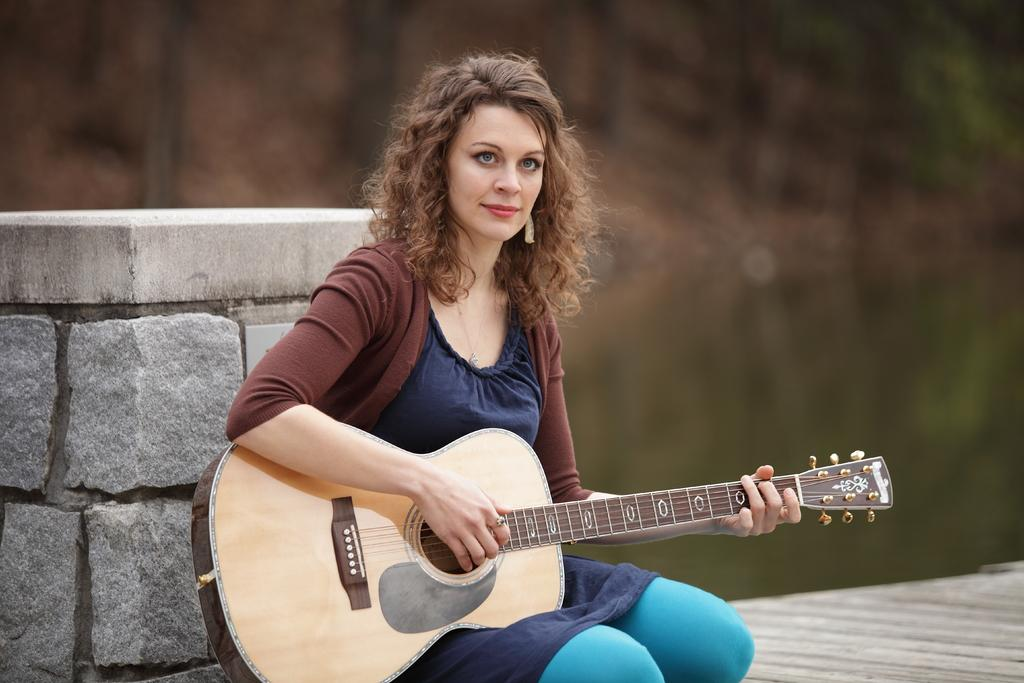Who is the main subject in the image? There is a woman in the image. What is the woman doing in the image? The woman is sitting on the floor and playing the guitar. What is the woman holding in the image? The woman is holding a guitar. How does the woman appear to feel while playing the guitar? The woman has a smile on her face, suggesting she is enjoying herself. What can be seen in the background of the image? There is a wall with stones in the background of the image. How many rings can be seen on the woman's fingers in the image? There is no mention of rings in the image, so we cannot determine the number of rings on the woman's fingers. 